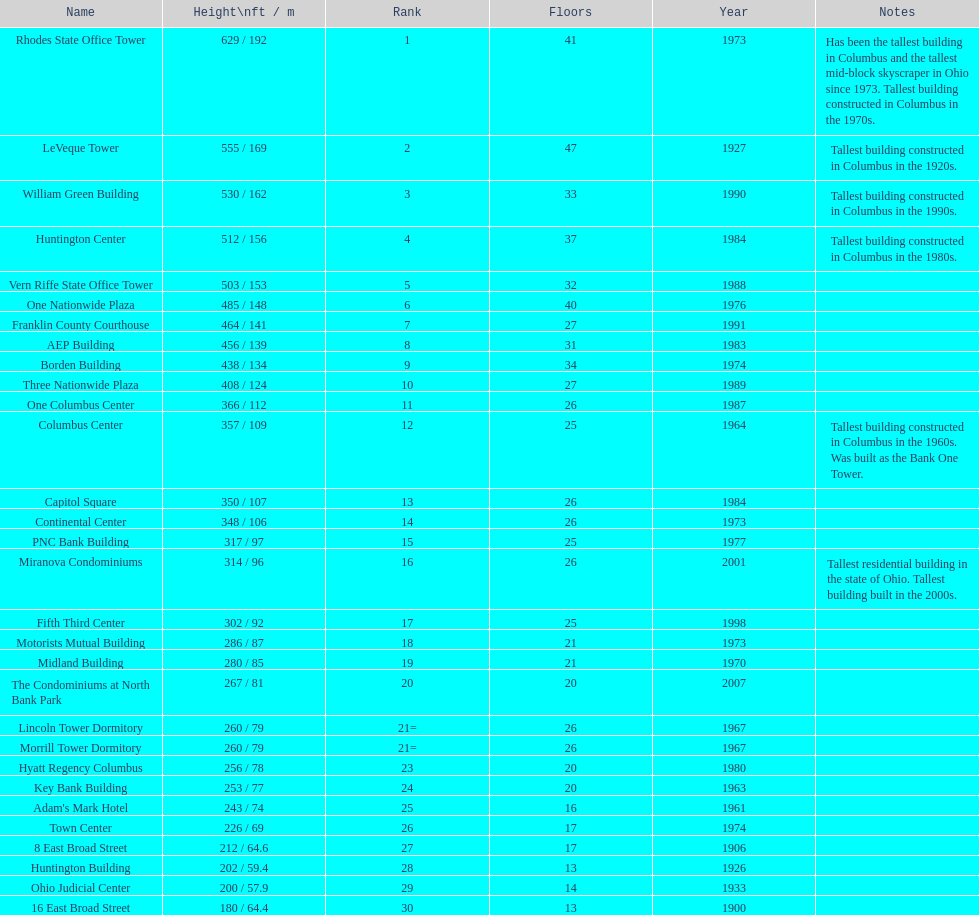Parse the full table. {'header': ['Name', 'Height\\nft / m', 'Rank', 'Floors', 'Year', 'Notes'], 'rows': [['Rhodes State Office Tower', '629 / 192', '1', '41', '1973', 'Has been the tallest building in Columbus and the tallest mid-block skyscraper in Ohio since 1973. Tallest building constructed in Columbus in the 1970s.'], ['LeVeque Tower', '555 / 169', '2', '47', '1927', 'Tallest building constructed in Columbus in the 1920s.'], ['William Green Building', '530 / 162', '3', '33', '1990', 'Tallest building constructed in Columbus in the 1990s.'], ['Huntington Center', '512 / 156', '4', '37', '1984', 'Tallest building constructed in Columbus in the 1980s.'], ['Vern Riffe State Office Tower', '503 / 153', '5', '32', '1988', ''], ['One Nationwide Plaza', '485 / 148', '6', '40', '1976', ''], ['Franklin County Courthouse', '464 / 141', '7', '27', '1991', ''], ['AEP Building', '456 / 139', '8', '31', '1983', ''], ['Borden Building', '438 / 134', '9', '34', '1974', ''], ['Three Nationwide Plaza', '408 / 124', '10', '27', '1989', ''], ['One Columbus Center', '366 / 112', '11', '26', '1987', ''], ['Columbus Center', '357 / 109', '12', '25', '1964', 'Tallest building constructed in Columbus in the 1960s. Was built as the Bank One Tower.'], ['Capitol Square', '350 / 107', '13', '26', '1984', ''], ['Continental Center', '348 / 106', '14', '26', '1973', ''], ['PNC Bank Building', '317 / 97', '15', '25', '1977', ''], ['Miranova Condominiums', '314 / 96', '16', '26', '2001', 'Tallest residential building in the state of Ohio. Tallest building built in the 2000s.'], ['Fifth Third Center', '302 / 92', '17', '25', '1998', ''], ['Motorists Mutual Building', '286 / 87', '18', '21', '1973', ''], ['Midland Building', '280 / 85', '19', '21', '1970', ''], ['The Condominiums at North Bank Park', '267 / 81', '20', '20', '2007', ''], ['Lincoln Tower Dormitory', '260 / 79', '21=', '26', '1967', ''], ['Morrill Tower Dormitory', '260 / 79', '21=', '26', '1967', ''], ['Hyatt Regency Columbus', '256 / 78', '23', '20', '1980', ''], ['Key Bank Building', '253 / 77', '24', '20', '1963', ''], ["Adam's Mark Hotel", '243 / 74', '25', '16', '1961', ''], ['Town Center', '226 / 69', '26', '17', '1974', ''], ['8 East Broad Street', '212 / 64.6', '27', '17', '1906', ''], ['Huntington Building', '202 / 59.4', '28', '13', '1926', ''], ['Ohio Judicial Center', '200 / 57.9', '29', '14', '1933', ''], ['16 East Broad Street', '180 / 64.4', '30', '13', '1900', '']]} Which is the tallest building? Rhodes State Office Tower. 